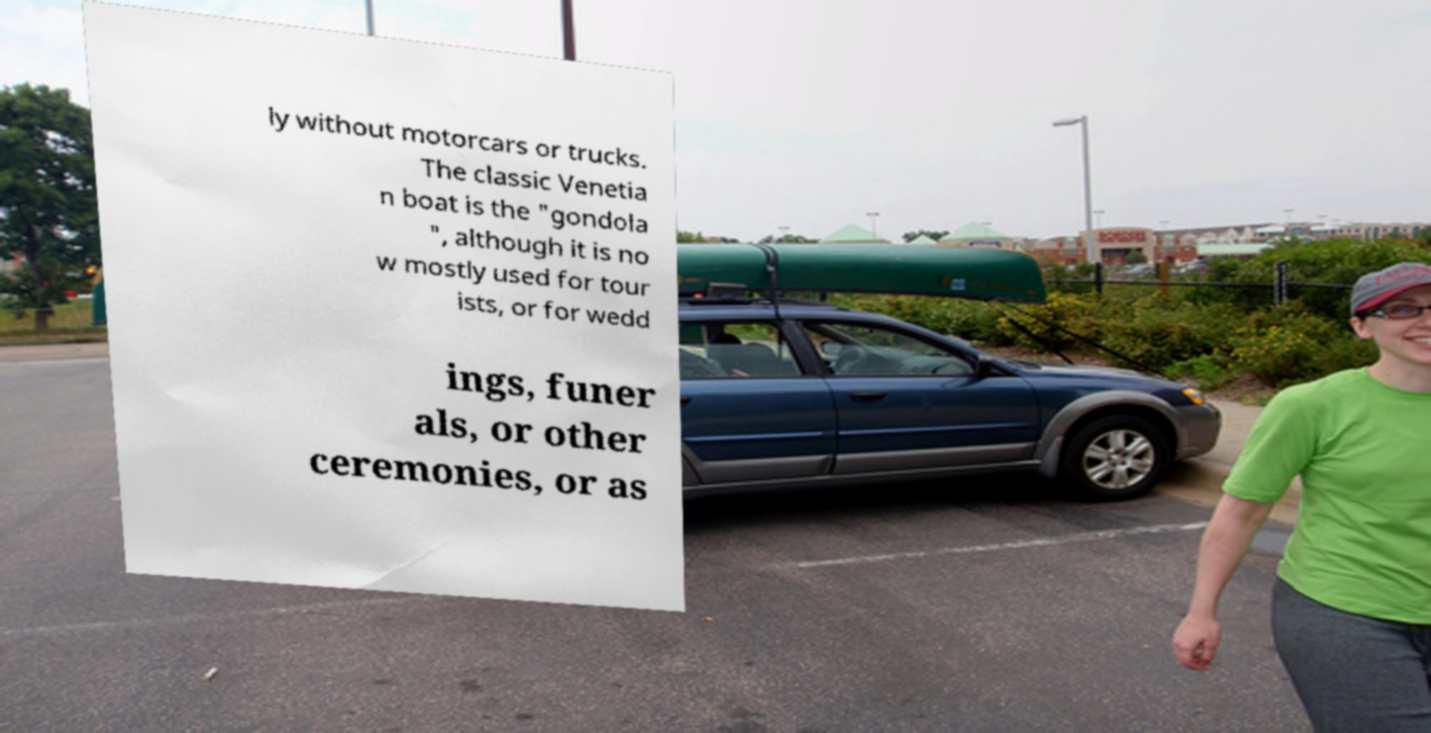Could you assist in decoding the text presented in this image and type it out clearly? ly without motorcars or trucks. The classic Venetia n boat is the "gondola ", although it is no w mostly used for tour ists, or for wedd ings, funer als, or other ceremonies, or as 